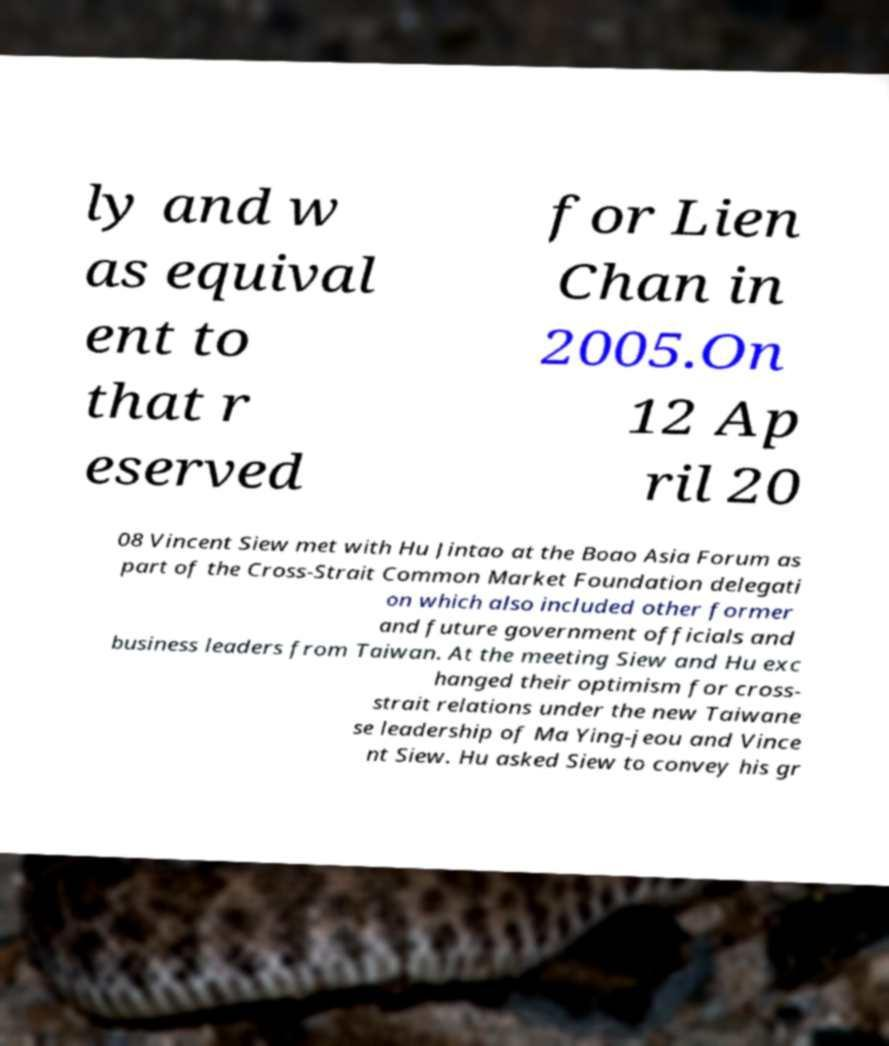Can you accurately transcribe the text from the provided image for me? ly and w as equival ent to that r eserved for Lien Chan in 2005.On 12 Ap ril 20 08 Vincent Siew met with Hu Jintao at the Boao Asia Forum as part of the Cross-Strait Common Market Foundation delegati on which also included other former and future government officials and business leaders from Taiwan. At the meeting Siew and Hu exc hanged their optimism for cross- strait relations under the new Taiwane se leadership of Ma Ying-jeou and Vince nt Siew. Hu asked Siew to convey his gr 